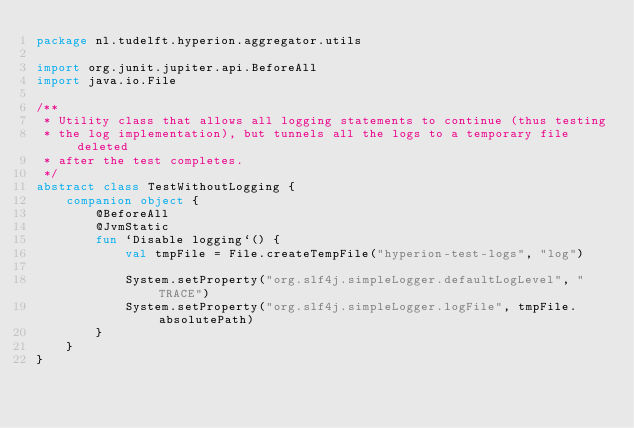Convert code to text. <code><loc_0><loc_0><loc_500><loc_500><_Kotlin_>package nl.tudelft.hyperion.aggregator.utils

import org.junit.jupiter.api.BeforeAll
import java.io.File

/**
 * Utility class that allows all logging statements to continue (thus testing
 * the log implementation), but tunnels all the logs to a temporary file deleted
 * after the test completes.
 */
abstract class TestWithoutLogging {
    companion object {
        @BeforeAll
        @JvmStatic
        fun `Disable logging`() {
            val tmpFile = File.createTempFile("hyperion-test-logs", "log")

            System.setProperty("org.slf4j.simpleLogger.defaultLogLevel", "TRACE")
            System.setProperty("org.slf4j.simpleLogger.logFile", tmpFile.absolutePath)
        }
    }
}
</code> 